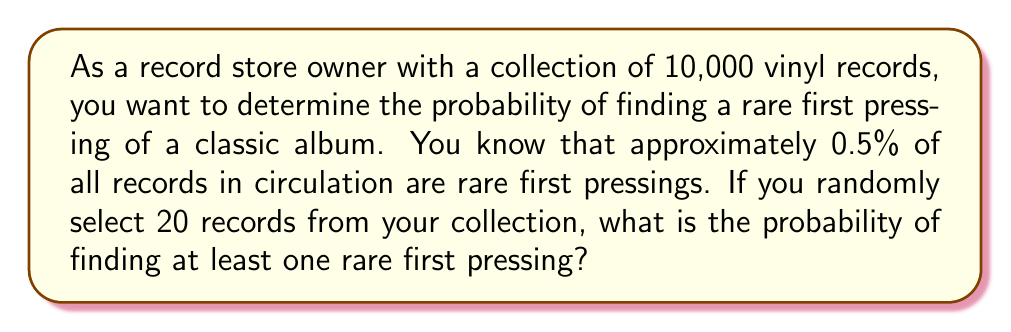Solve this math problem. To solve this problem, we'll use the binomial probability distribution and the complement rule.

1. Let's define our variables:
   $n = 20$ (number of records selected)
   $p = 0.005$ (probability of a record being a rare first pressing)
   $q = 1 - p = 0.995$ (probability of a record not being a rare first pressing)

2. We want to find the probability of at least one success in 20 trials. It's easier to calculate the probability of no successes and then subtract from 1.

3. The probability of no rare first pressings in 20 selections is:
   $$P(\text{no rare pressings}) = q^n = 0.995^{20}$$

4. Using a calculator or computer, we can evaluate this:
   $$0.995^{20} \approx 0.9048$$

5. The probability of at least one rare first pressing is the complement of this probability:
   $$P(\text{at least one rare pressing}) = 1 - P(\text{no rare pressings})$$
   $$= 1 - 0.9048 \approx 0.0952$$

6. Convert to a percentage:
   $$0.0952 \times 100\% = 9.52\%$$

Therefore, the probability of finding at least one rare first pressing when randomly selecting 20 records from your collection is approximately 9.52%.
Answer: 9.52% 